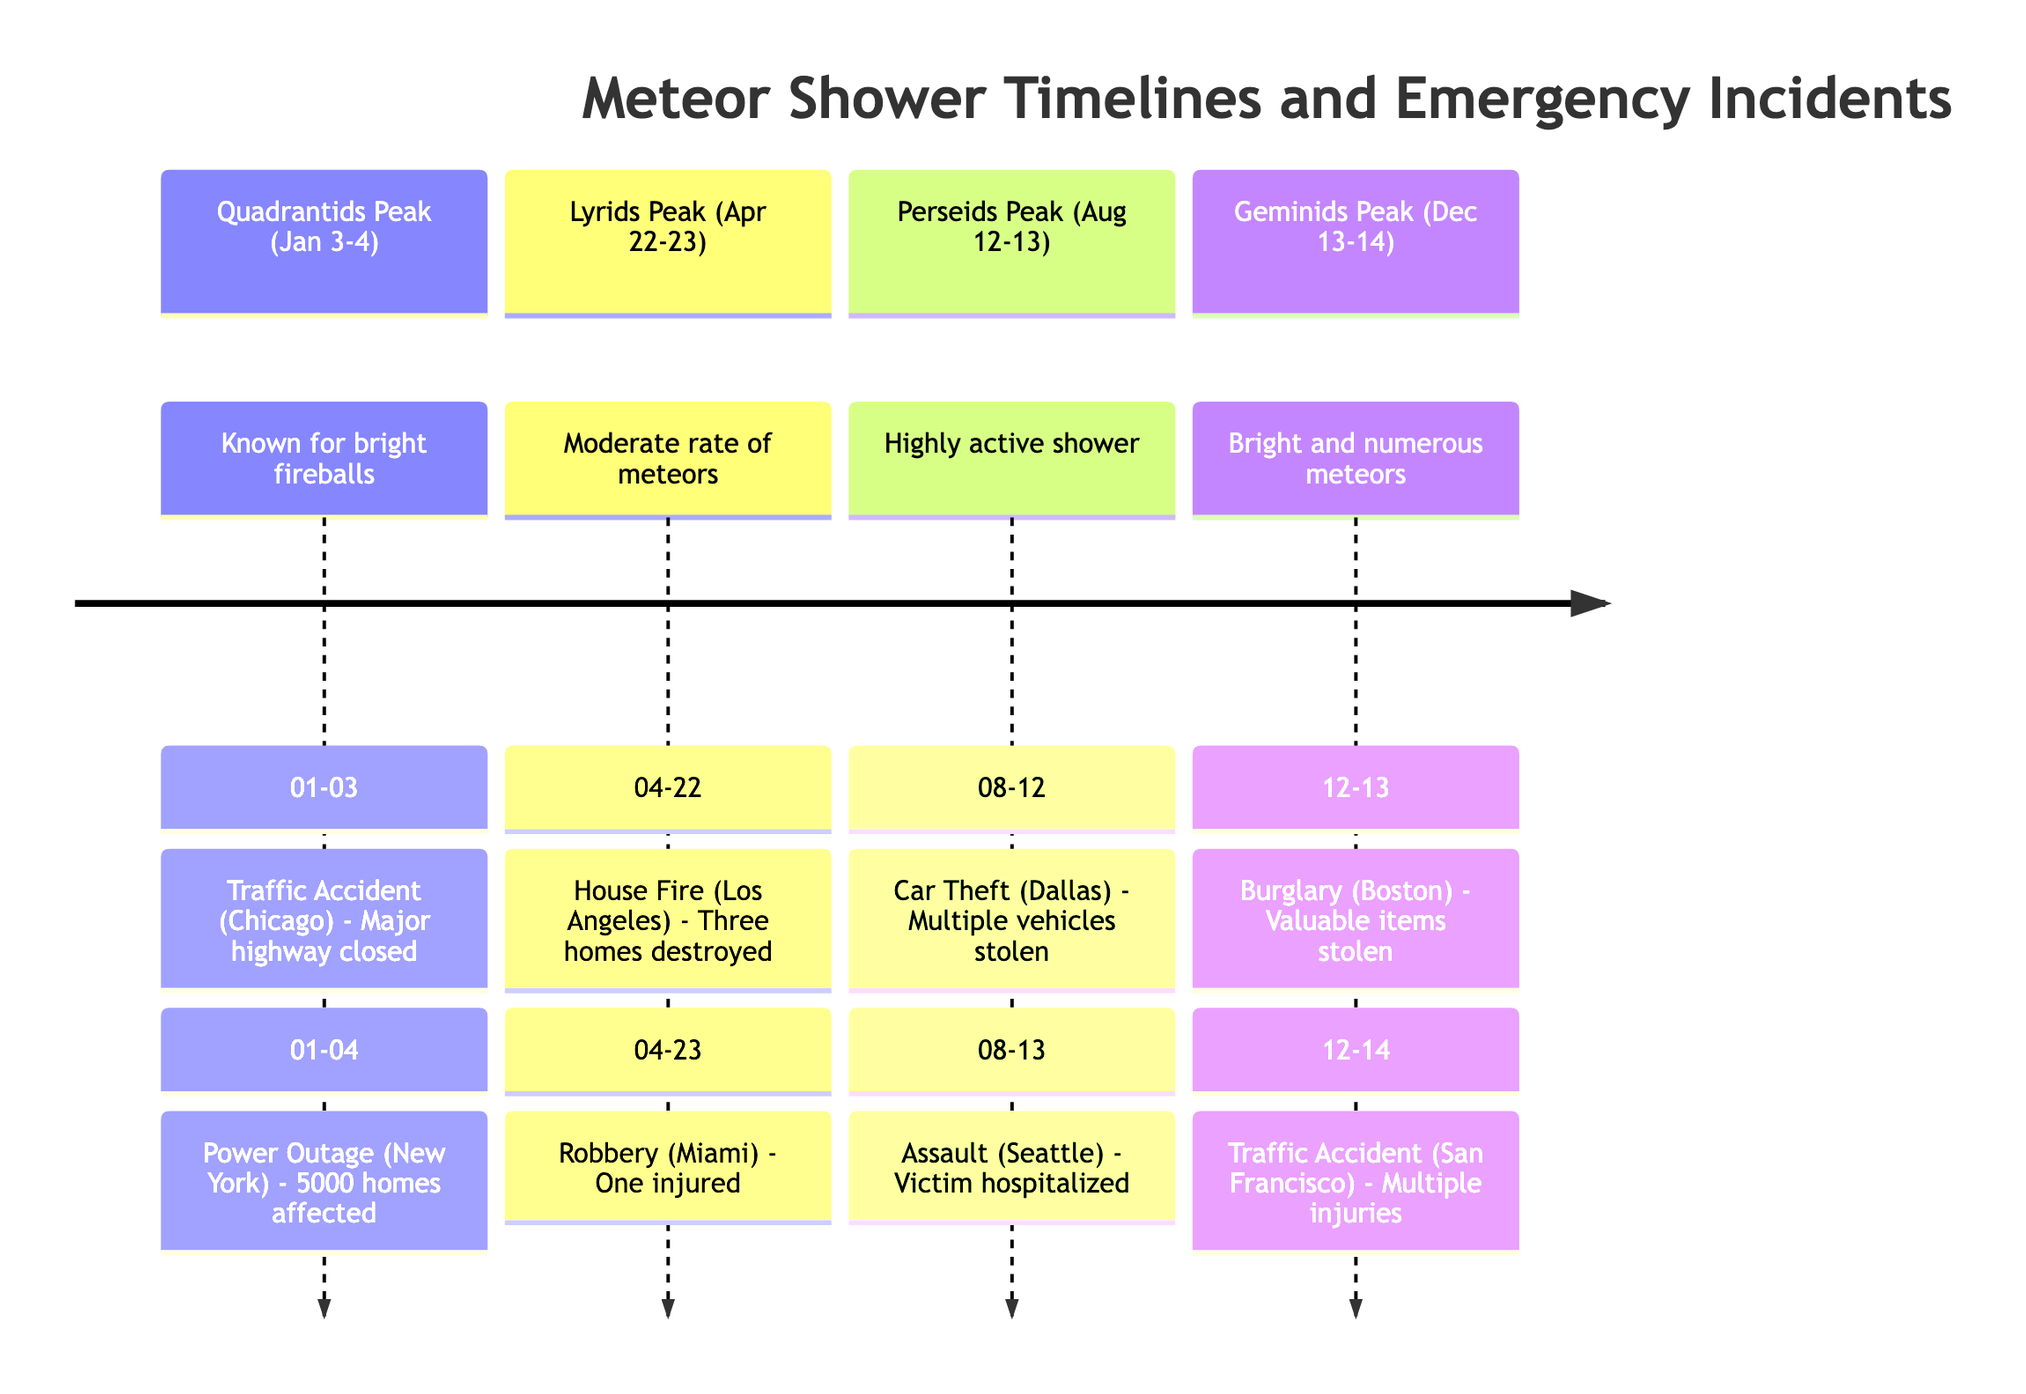What incident occurred on January 4 during the Quadrantids? On January 4, there was a power outage in New York affecting 5000 homes.
Answer: Power Outage (New York) How many emergency incidents are listed for the Lyrids peak? The Lyrids peak has two incidents: a house fire and a robbery.
Answer: 2 What was the nature of the incident reported on August 13 during the Perseids peak? On August 13, there was an assault in Seattle where the victim was hospitalized.
Answer: Assault (Seattle) Which meteor shower is associated with a traffic accident on December 14? The Geminids meteor shower is associated with a traffic accident on December 14 in San Francisco.
Answer: Geminids Which month is the Quadrantids meteor shower peak in? The peak of the Quadrantids meteor shower is in January.
Answer: January Which incident had the most severe consequence according to the diagram? The house fire in Los Angeles destroyed three homes, indicating severe consequences.
Answer: House Fire (Los Angeles) What type of meteor shower is associated with the most emergency incidents? The Perseids peak is associated with multiple incidents: a car theft and an assault.
Answer: Perseids On which date did a robbery occur during the Lyrids peak? A robbery occurred on April 23 during the Lyrids peak.
Answer: April 23 How many meteors are associated with the Geminids peak? The Geminids peak is characterized as having bright and numerous meteors, but no specific count is given.
Answer: Numerous 